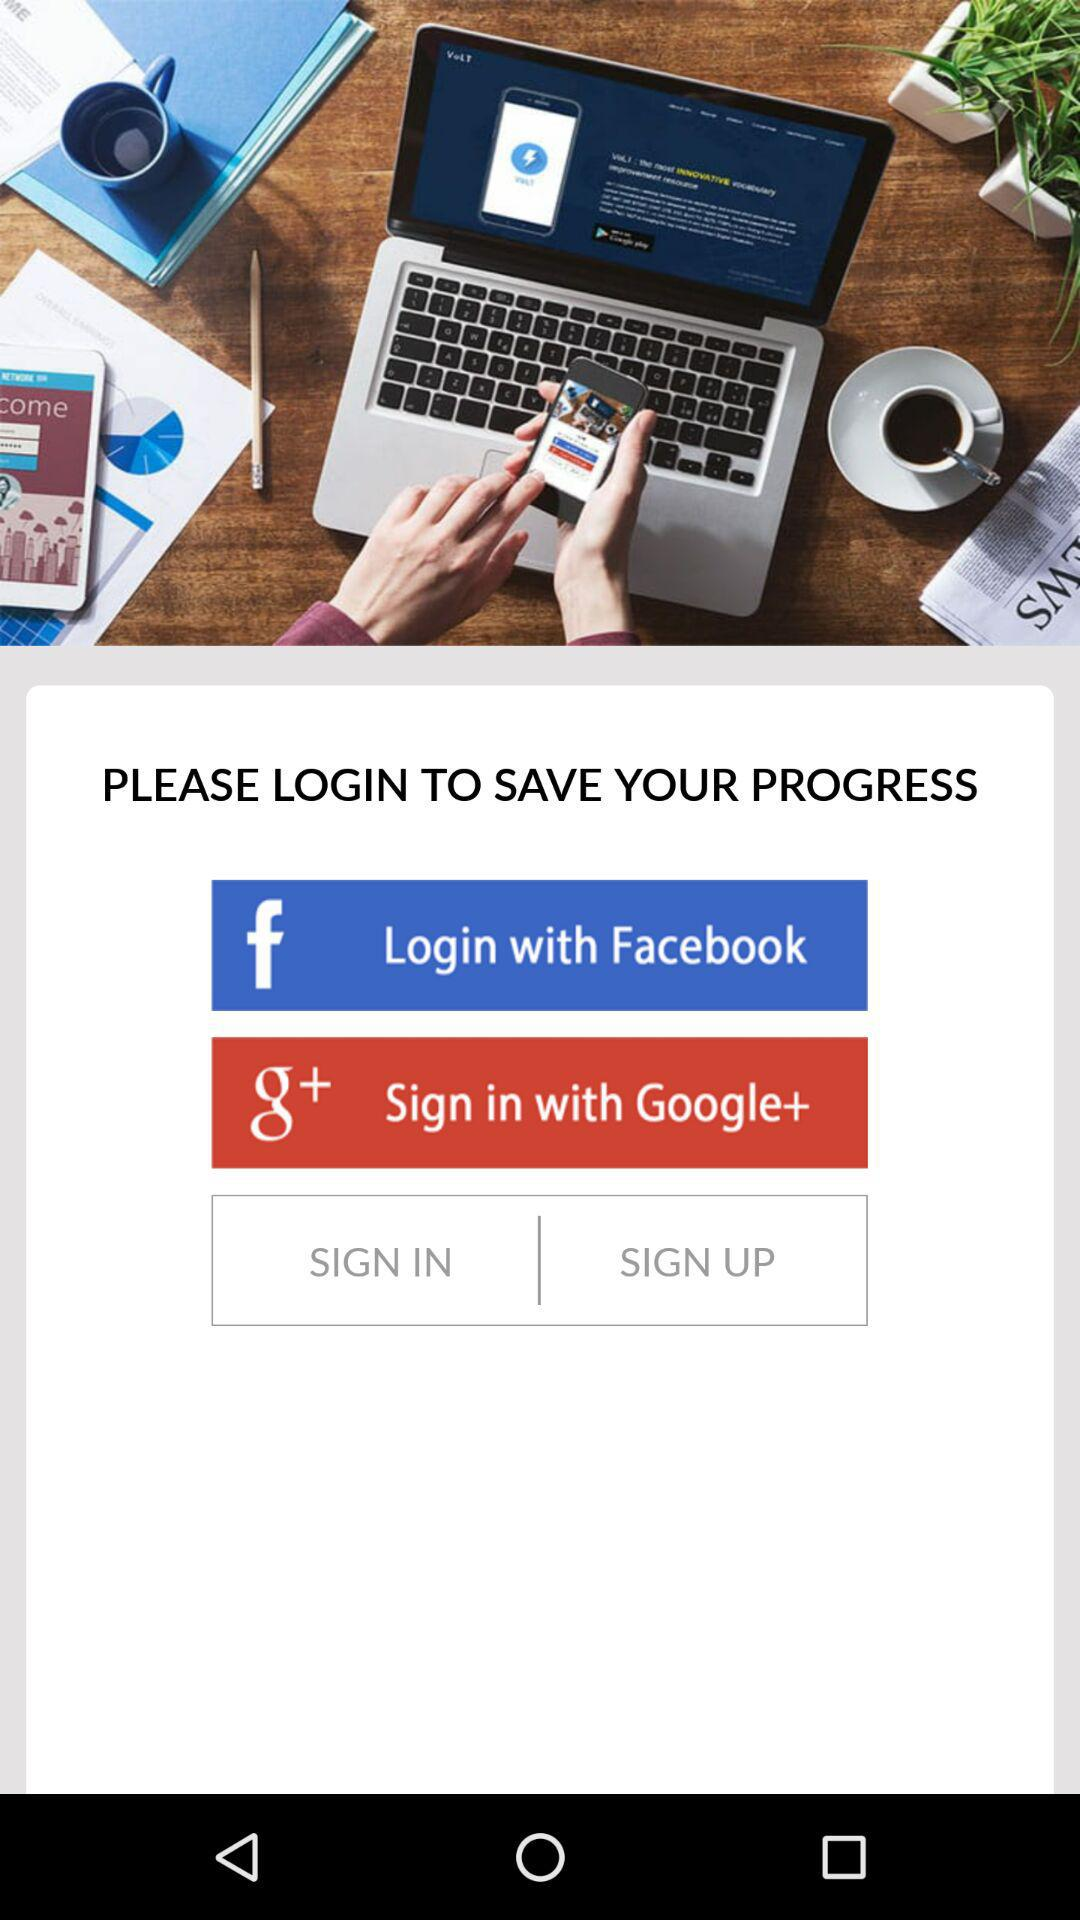What are the given login options? The given login options are "Facebook" and "Google+". 